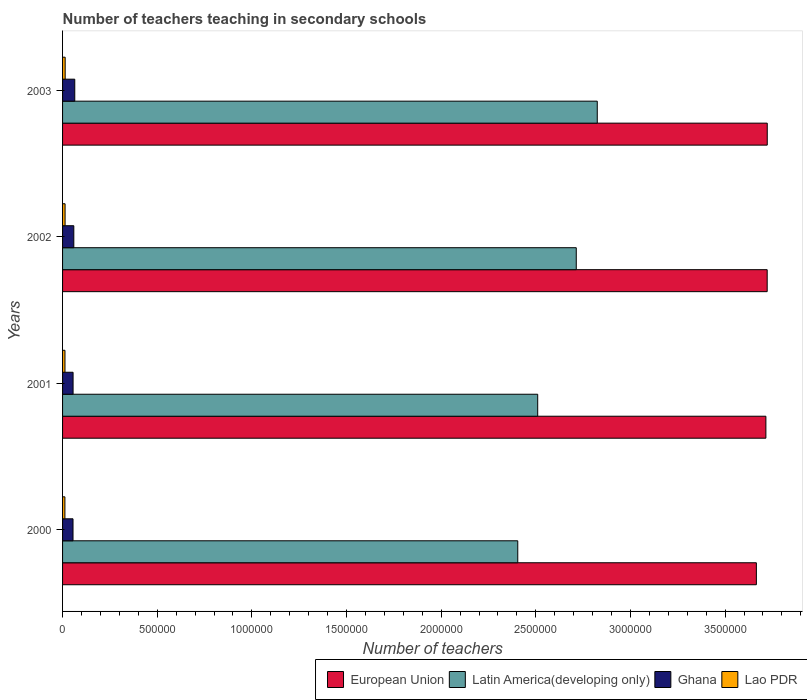How many different coloured bars are there?
Give a very brief answer. 4. Are the number of bars per tick equal to the number of legend labels?
Provide a succinct answer. Yes. How many bars are there on the 2nd tick from the top?
Your answer should be very brief. 4. How many bars are there on the 1st tick from the bottom?
Provide a short and direct response. 4. What is the number of teachers teaching in secondary schools in European Union in 2003?
Give a very brief answer. 3.72e+06. Across all years, what is the maximum number of teachers teaching in secondary schools in Ghana?
Offer a very short reply. 6.44e+04. Across all years, what is the minimum number of teachers teaching in secondary schools in Lao PDR?
Your response must be concise. 1.24e+04. In which year was the number of teachers teaching in secondary schools in Ghana maximum?
Offer a terse response. 2003. What is the total number of teachers teaching in secondary schools in Latin America(developing only) in the graph?
Provide a succinct answer. 1.05e+07. What is the difference between the number of teachers teaching in secondary schools in Latin America(developing only) in 2001 and that in 2002?
Give a very brief answer. -2.04e+05. What is the difference between the number of teachers teaching in secondary schools in European Union in 2000 and the number of teachers teaching in secondary schools in Lao PDR in 2001?
Offer a terse response. 3.65e+06. What is the average number of teachers teaching in secondary schools in Ghana per year?
Make the answer very short. 5.87e+04. In the year 2001, what is the difference between the number of teachers teaching in secondary schools in European Union and number of teachers teaching in secondary schools in Latin America(developing only)?
Your response must be concise. 1.21e+06. In how many years, is the number of teachers teaching in secondary schools in Lao PDR greater than 2000000 ?
Give a very brief answer. 0. What is the ratio of the number of teachers teaching in secondary schools in Latin America(developing only) in 2000 to that in 2001?
Offer a terse response. 0.96. Is the difference between the number of teachers teaching in secondary schools in European Union in 2000 and 2001 greater than the difference between the number of teachers teaching in secondary schools in Latin America(developing only) in 2000 and 2001?
Provide a short and direct response. Yes. What is the difference between the highest and the second highest number of teachers teaching in secondary schools in Lao PDR?
Ensure brevity in your answer.  475. What is the difference between the highest and the lowest number of teachers teaching in secondary schools in Ghana?
Your answer should be compact. 9202. In how many years, is the number of teachers teaching in secondary schools in Ghana greater than the average number of teachers teaching in secondary schools in Ghana taken over all years?
Keep it short and to the point. 2. Is the sum of the number of teachers teaching in secondary schools in Ghana in 2000 and 2002 greater than the maximum number of teachers teaching in secondary schools in Latin America(developing only) across all years?
Your answer should be compact. No. Is it the case that in every year, the sum of the number of teachers teaching in secondary schools in Lao PDR and number of teachers teaching in secondary schools in European Union is greater than the sum of number of teachers teaching in secondary schools in Latin America(developing only) and number of teachers teaching in secondary schools in Ghana?
Give a very brief answer. No. What does the 4th bar from the bottom in 2003 represents?
Give a very brief answer. Lao PDR. Is it the case that in every year, the sum of the number of teachers teaching in secondary schools in European Union and number of teachers teaching in secondary schools in Ghana is greater than the number of teachers teaching in secondary schools in Lao PDR?
Your response must be concise. Yes. Are all the bars in the graph horizontal?
Ensure brevity in your answer.  Yes. How many years are there in the graph?
Make the answer very short. 4. What is the difference between two consecutive major ticks on the X-axis?
Ensure brevity in your answer.  5.00e+05. Are the values on the major ticks of X-axis written in scientific E-notation?
Provide a succinct answer. No. Does the graph contain grids?
Your response must be concise. No. Where does the legend appear in the graph?
Offer a very short reply. Bottom right. What is the title of the graph?
Your response must be concise. Number of teachers teaching in secondary schools. What is the label or title of the X-axis?
Keep it short and to the point. Number of teachers. What is the label or title of the Y-axis?
Give a very brief answer. Years. What is the Number of teachers of European Union in 2000?
Your answer should be compact. 3.67e+06. What is the Number of teachers in Latin America(developing only) in 2000?
Your response must be concise. 2.40e+06. What is the Number of teachers of Ghana in 2000?
Provide a succinct answer. 5.52e+04. What is the Number of teachers in Lao PDR in 2000?
Give a very brief answer. 1.24e+04. What is the Number of teachers in European Union in 2001?
Offer a terse response. 3.72e+06. What is the Number of teachers of Latin America(developing only) in 2001?
Make the answer very short. 2.51e+06. What is the Number of teachers in Ghana in 2001?
Your answer should be very brief. 5.55e+04. What is the Number of teachers in Lao PDR in 2001?
Your answer should be very brief. 1.27e+04. What is the Number of teachers of European Union in 2002?
Your answer should be very brief. 3.72e+06. What is the Number of teachers in Latin America(developing only) in 2002?
Make the answer very short. 2.71e+06. What is the Number of teachers in Ghana in 2002?
Keep it short and to the point. 5.94e+04. What is the Number of teachers in Lao PDR in 2002?
Your answer should be compact. 1.33e+04. What is the Number of teachers of European Union in 2003?
Ensure brevity in your answer.  3.72e+06. What is the Number of teachers of Latin America(developing only) in 2003?
Provide a succinct answer. 2.82e+06. What is the Number of teachers in Ghana in 2003?
Your answer should be compact. 6.44e+04. What is the Number of teachers in Lao PDR in 2003?
Make the answer very short. 1.38e+04. Across all years, what is the maximum Number of teachers in European Union?
Offer a very short reply. 3.72e+06. Across all years, what is the maximum Number of teachers in Latin America(developing only)?
Provide a succinct answer. 2.82e+06. Across all years, what is the maximum Number of teachers in Ghana?
Provide a succinct answer. 6.44e+04. Across all years, what is the maximum Number of teachers in Lao PDR?
Provide a short and direct response. 1.38e+04. Across all years, what is the minimum Number of teachers of European Union?
Keep it short and to the point. 3.67e+06. Across all years, what is the minimum Number of teachers in Latin America(developing only)?
Provide a succinct answer. 2.40e+06. Across all years, what is the minimum Number of teachers in Ghana?
Make the answer very short. 5.52e+04. Across all years, what is the minimum Number of teachers in Lao PDR?
Offer a terse response. 1.24e+04. What is the total Number of teachers in European Union in the graph?
Make the answer very short. 1.48e+07. What is the total Number of teachers in Latin America(developing only) in the graph?
Give a very brief answer. 1.05e+07. What is the total Number of teachers in Ghana in the graph?
Offer a terse response. 2.35e+05. What is the total Number of teachers in Lao PDR in the graph?
Provide a succinct answer. 5.22e+04. What is the difference between the Number of teachers of European Union in 2000 and that in 2001?
Offer a terse response. -5.02e+04. What is the difference between the Number of teachers in Latin America(developing only) in 2000 and that in 2001?
Offer a very short reply. -1.05e+05. What is the difference between the Number of teachers in Ghana in 2000 and that in 2001?
Your response must be concise. -332. What is the difference between the Number of teachers of Lao PDR in 2000 and that in 2001?
Provide a succinct answer. -284. What is the difference between the Number of teachers in European Union in 2000 and that in 2002?
Offer a very short reply. -5.71e+04. What is the difference between the Number of teachers of Latin America(developing only) in 2000 and that in 2002?
Provide a succinct answer. -3.09e+05. What is the difference between the Number of teachers of Ghana in 2000 and that in 2002?
Offer a very short reply. -4221. What is the difference between the Number of teachers of Lao PDR in 2000 and that in 2002?
Make the answer very short. -894. What is the difference between the Number of teachers in European Union in 2000 and that in 2003?
Provide a succinct answer. -5.75e+04. What is the difference between the Number of teachers in Latin America(developing only) in 2000 and that in 2003?
Provide a short and direct response. -4.20e+05. What is the difference between the Number of teachers in Ghana in 2000 and that in 2003?
Offer a terse response. -9202. What is the difference between the Number of teachers in Lao PDR in 2000 and that in 2003?
Keep it short and to the point. -1369. What is the difference between the Number of teachers of European Union in 2001 and that in 2002?
Make the answer very short. -6899.25. What is the difference between the Number of teachers in Latin America(developing only) in 2001 and that in 2002?
Give a very brief answer. -2.04e+05. What is the difference between the Number of teachers of Ghana in 2001 and that in 2002?
Provide a succinct answer. -3889. What is the difference between the Number of teachers in Lao PDR in 2001 and that in 2002?
Make the answer very short. -610. What is the difference between the Number of teachers of European Union in 2001 and that in 2003?
Ensure brevity in your answer.  -7258. What is the difference between the Number of teachers in Latin America(developing only) in 2001 and that in 2003?
Your answer should be very brief. -3.15e+05. What is the difference between the Number of teachers of Ghana in 2001 and that in 2003?
Your response must be concise. -8870. What is the difference between the Number of teachers in Lao PDR in 2001 and that in 2003?
Your answer should be compact. -1085. What is the difference between the Number of teachers of European Union in 2002 and that in 2003?
Ensure brevity in your answer.  -358.75. What is the difference between the Number of teachers of Latin America(developing only) in 2002 and that in 2003?
Your answer should be compact. -1.11e+05. What is the difference between the Number of teachers in Ghana in 2002 and that in 2003?
Your answer should be compact. -4981. What is the difference between the Number of teachers in Lao PDR in 2002 and that in 2003?
Offer a terse response. -475. What is the difference between the Number of teachers of European Union in 2000 and the Number of teachers of Latin America(developing only) in 2001?
Your answer should be compact. 1.16e+06. What is the difference between the Number of teachers of European Union in 2000 and the Number of teachers of Ghana in 2001?
Offer a very short reply. 3.61e+06. What is the difference between the Number of teachers of European Union in 2000 and the Number of teachers of Lao PDR in 2001?
Offer a very short reply. 3.65e+06. What is the difference between the Number of teachers of Latin America(developing only) in 2000 and the Number of teachers of Ghana in 2001?
Your answer should be compact. 2.35e+06. What is the difference between the Number of teachers of Latin America(developing only) in 2000 and the Number of teachers of Lao PDR in 2001?
Provide a succinct answer. 2.39e+06. What is the difference between the Number of teachers of Ghana in 2000 and the Number of teachers of Lao PDR in 2001?
Provide a short and direct response. 4.25e+04. What is the difference between the Number of teachers of European Union in 2000 and the Number of teachers of Latin America(developing only) in 2002?
Your answer should be very brief. 9.52e+05. What is the difference between the Number of teachers in European Union in 2000 and the Number of teachers in Ghana in 2002?
Ensure brevity in your answer.  3.61e+06. What is the difference between the Number of teachers in European Union in 2000 and the Number of teachers in Lao PDR in 2002?
Ensure brevity in your answer.  3.65e+06. What is the difference between the Number of teachers of Latin America(developing only) in 2000 and the Number of teachers of Ghana in 2002?
Your answer should be compact. 2.35e+06. What is the difference between the Number of teachers in Latin America(developing only) in 2000 and the Number of teachers in Lao PDR in 2002?
Provide a succinct answer. 2.39e+06. What is the difference between the Number of teachers of Ghana in 2000 and the Number of teachers of Lao PDR in 2002?
Offer a terse response. 4.19e+04. What is the difference between the Number of teachers of European Union in 2000 and the Number of teachers of Latin America(developing only) in 2003?
Your response must be concise. 8.41e+05. What is the difference between the Number of teachers of European Union in 2000 and the Number of teachers of Ghana in 2003?
Your answer should be compact. 3.60e+06. What is the difference between the Number of teachers in European Union in 2000 and the Number of teachers in Lao PDR in 2003?
Offer a terse response. 3.65e+06. What is the difference between the Number of teachers in Latin America(developing only) in 2000 and the Number of teachers in Ghana in 2003?
Offer a very short reply. 2.34e+06. What is the difference between the Number of teachers of Latin America(developing only) in 2000 and the Number of teachers of Lao PDR in 2003?
Your answer should be very brief. 2.39e+06. What is the difference between the Number of teachers in Ghana in 2000 and the Number of teachers in Lao PDR in 2003?
Make the answer very short. 4.14e+04. What is the difference between the Number of teachers in European Union in 2001 and the Number of teachers in Latin America(developing only) in 2002?
Your response must be concise. 1.00e+06. What is the difference between the Number of teachers of European Union in 2001 and the Number of teachers of Ghana in 2002?
Your answer should be very brief. 3.66e+06. What is the difference between the Number of teachers of European Union in 2001 and the Number of teachers of Lao PDR in 2002?
Offer a very short reply. 3.70e+06. What is the difference between the Number of teachers in Latin America(developing only) in 2001 and the Number of teachers in Ghana in 2002?
Ensure brevity in your answer.  2.45e+06. What is the difference between the Number of teachers of Latin America(developing only) in 2001 and the Number of teachers of Lao PDR in 2002?
Ensure brevity in your answer.  2.50e+06. What is the difference between the Number of teachers of Ghana in 2001 and the Number of teachers of Lao PDR in 2002?
Offer a terse response. 4.23e+04. What is the difference between the Number of teachers in European Union in 2001 and the Number of teachers in Latin America(developing only) in 2003?
Give a very brief answer. 8.91e+05. What is the difference between the Number of teachers of European Union in 2001 and the Number of teachers of Ghana in 2003?
Offer a terse response. 3.65e+06. What is the difference between the Number of teachers in European Union in 2001 and the Number of teachers in Lao PDR in 2003?
Your answer should be very brief. 3.70e+06. What is the difference between the Number of teachers in Latin America(developing only) in 2001 and the Number of teachers in Ghana in 2003?
Offer a very short reply. 2.45e+06. What is the difference between the Number of teachers of Latin America(developing only) in 2001 and the Number of teachers of Lao PDR in 2003?
Your answer should be compact. 2.50e+06. What is the difference between the Number of teachers in Ghana in 2001 and the Number of teachers in Lao PDR in 2003?
Offer a terse response. 4.18e+04. What is the difference between the Number of teachers of European Union in 2002 and the Number of teachers of Latin America(developing only) in 2003?
Provide a succinct answer. 8.98e+05. What is the difference between the Number of teachers of European Union in 2002 and the Number of teachers of Ghana in 2003?
Keep it short and to the point. 3.66e+06. What is the difference between the Number of teachers in European Union in 2002 and the Number of teachers in Lao PDR in 2003?
Keep it short and to the point. 3.71e+06. What is the difference between the Number of teachers in Latin America(developing only) in 2002 and the Number of teachers in Ghana in 2003?
Make the answer very short. 2.65e+06. What is the difference between the Number of teachers of Latin America(developing only) in 2002 and the Number of teachers of Lao PDR in 2003?
Offer a very short reply. 2.70e+06. What is the difference between the Number of teachers of Ghana in 2002 and the Number of teachers of Lao PDR in 2003?
Ensure brevity in your answer.  4.57e+04. What is the average Number of teachers of European Union per year?
Provide a short and direct response. 3.71e+06. What is the average Number of teachers of Latin America(developing only) per year?
Ensure brevity in your answer.  2.61e+06. What is the average Number of teachers in Ghana per year?
Your answer should be compact. 5.87e+04. What is the average Number of teachers of Lao PDR per year?
Offer a terse response. 1.30e+04. In the year 2000, what is the difference between the Number of teachers of European Union and Number of teachers of Latin America(developing only)?
Ensure brevity in your answer.  1.26e+06. In the year 2000, what is the difference between the Number of teachers of European Union and Number of teachers of Ghana?
Provide a short and direct response. 3.61e+06. In the year 2000, what is the difference between the Number of teachers in European Union and Number of teachers in Lao PDR?
Your answer should be compact. 3.65e+06. In the year 2000, what is the difference between the Number of teachers in Latin America(developing only) and Number of teachers in Ghana?
Give a very brief answer. 2.35e+06. In the year 2000, what is the difference between the Number of teachers in Latin America(developing only) and Number of teachers in Lao PDR?
Make the answer very short. 2.39e+06. In the year 2000, what is the difference between the Number of teachers in Ghana and Number of teachers in Lao PDR?
Offer a terse response. 4.28e+04. In the year 2001, what is the difference between the Number of teachers in European Union and Number of teachers in Latin America(developing only)?
Your answer should be very brief. 1.21e+06. In the year 2001, what is the difference between the Number of teachers in European Union and Number of teachers in Ghana?
Ensure brevity in your answer.  3.66e+06. In the year 2001, what is the difference between the Number of teachers in European Union and Number of teachers in Lao PDR?
Keep it short and to the point. 3.70e+06. In the year 2001, what is the difference between the Number of teachers in Latin America(developing only) and Number of teachers in Ghana?
Provide a succinct answer. 2.45e+06. In the year 2001, what is the difference between the Number of teachers of Latin America(developing only) and Number of teachers of Lao PDR?
Provide a short and direct response. 2.50e+06. In the year 2001, what is the difference between the Number of teachers in Ghana and Number of teachers in Lao PDR?
Give a very brief answer. 4.29e+04. In the year 2002, what is the difference between the Number of teachers of European Union and Number of teachers of Latin America(developing only)?
Keep it short and to the point. 1.01e+06. In the year 2002, what is the difference between the Number of teachers of European Union and Number of teachers of Ghana?
Provide a succinct answer. 3.66e+06. In the year 2002, what is the difference between the Number of teachers in European Union and Number of teachers in Lao PDR?
Provide a short and direct response. 3.71e+06. In the year 2002, what is the difference between the Number of teachers of Latin America(developing only) and Number of teachers of Ghana?
Your answer should be very brief. 2.65e+06. In the year 2002, what is the difference between the Number of teachers in Latin America(developing only) and Number of teachers in Lao PDR?
Provide a succinct answer. 2.70e+06. In the year 2002, what is the difference between the Number of teachers of Ghana and Number of teachers of Lao PDR?
Your answer should be compact. 4.61e+04. In the year 2003, what is the difference between the Number of teachers of European Union and Number of teachers of Latin America(developing only)?
Offer a very short reply. 8.98e+05. In the year 2003, what is the difference between the Number of teachers in European Union and Number of teachers in Ghana?
Make the answer very short. 3.66e+06. In the year 2003, what is the difference between the Number of teachers of European Union and Number of teachers of Lao PDR?
Offer a terse response. 3.71e+06. In the year 2003, what is the difference between the Number of teachers of Latin America(developing only) and Number of teachers of Ghana?
Keep it short and to the point. 2.76e+06. In the year 2003, what is the difference between the Number of teachers of Latin America(developing only) and Number of teachers of Lao PDR?
Ensure brevity in your answer.  2.81e+06. In the year 2003, what is the difference between the Number of teachers of Ghana and Number of teachers of Lao PDR?
Your answer should be compact. 5.06e+04. What is the ratio of the Number of teachers of European Union in 2000 to that in 2001?
Your answer should be very brief. 0.99. What is the ratio of the Number of teachers of Latin America(developing only) in 2000 to that in 2001?
Keep it short and to the point. 0.96. What is the ratio of the Number of teachers of Lao PDR in 2000 to that in 2001?
Your answer should be compact. 0.98. What is the ratio of the Number of teachers of European Union in 2000 to that in 2002?
Give a very brief answer. 0.98. What is the ratio of the Number of teachers of Latin America(developing only) in 2000 to that in 2002?
Your answer should be compact. 0.89. What is the ratio of the Number of teachers of Ghana in 2000 to that in 2002?
Provide a succinct answer. 0.93. What is the ratio of the Number of teachers of Lao PDR in 2000 to that in 2002?
Make the answer very short. 0.93. What is the ratio of the Number of teachers in European Union in 2000 to that in 2003?
Ensure brevity in your answer.  0.98. What is the ratio of the Number of teachers of Latin America(developing only) in 2000 to that in 2003?
Ensure brevity in your answer.  0.85. What is the ratio of the Number of teachers of Ghana in 2000 to that in 2003?
Make the answer very short. 0.86. What is the ratio of the Number of teachers of Lao PDR in 2000 to that in 2003?
Offer a very short reply. 0.9. What is the ratio of the Number of teachers in European Union in 2001 to that in 2002?
Offer a very short reply. 1. What is the ratio of the Number of teachers of Latin America(developing only) in 2001 to that in 2002?
Provide a short and direct response. 0.92. What is the ratio of the Number of teachers in Ghana in 2001 to that in 2002?
Provide a succinct answer. 0.93. What is the ratio of the Number of teachers of Lao PDR in 2001 to that in 2002?
Provide a succinct answer. 0.95. What is the ratio of the Number of teachers of European Union in 2001 to that in 2003?
Your response must be concise. 1. What is the ratio of the Number of teachers in Latin America(developing only) in 2001 to that in 2003?
Your answer should be very brief. 0.89. What is the ratio of the Number of teachers in Ghana in 2001 to that in 2003?
Provide a short and direct response. 0.86. What is the ratio of the Number of teachers in Lao PDR in 2001 to that in 2003?
Make the answer very short. 0.92. What is the ratio of the Number of teachers in Latin America(developing only) in 2002 to that in 2003?
Offer a terse response. 0.96. What is the ratio of the Number of teachers in Ghana in 2002 to that in 2003?
Your answer should be compact. 0.92. What is the ratio of the Number of teachers of Lao PDR in 2002 to that in 2003?
Your answer should be very brief. 0.97. What is the difference between the highest and the second highest Number of teachers of European Union?
Provide a succinct answer. 358.75. What is the difference between the highest and the second highest Number of teachers in Latin America(developing only)?
Your answer should be compact. 1.11e+05. What is the difference between the highest and the second highest Number of teachers of Ghana?
Your answer should be compact. 4981. What is the difference between the highest and the second highest Number of teachers in Lao PDR?
Your response must be concise. 475. What is the difference between the highest and the lowest Number of teachers in European Union?
Make the answer very short. 5.75e+04. What is the difference between the highest and the lowest Number of teachers in Latin America(developing only)?
Give a very brief answer. 4.20e+05. What is the difference between the highest and the lowest Number of teachers of Ghana?
Your answer should be very brief. 9202. What is the difference between the highest and the lowest Number of teachers in Lao PDR?
Your response must be concise. 1369. 